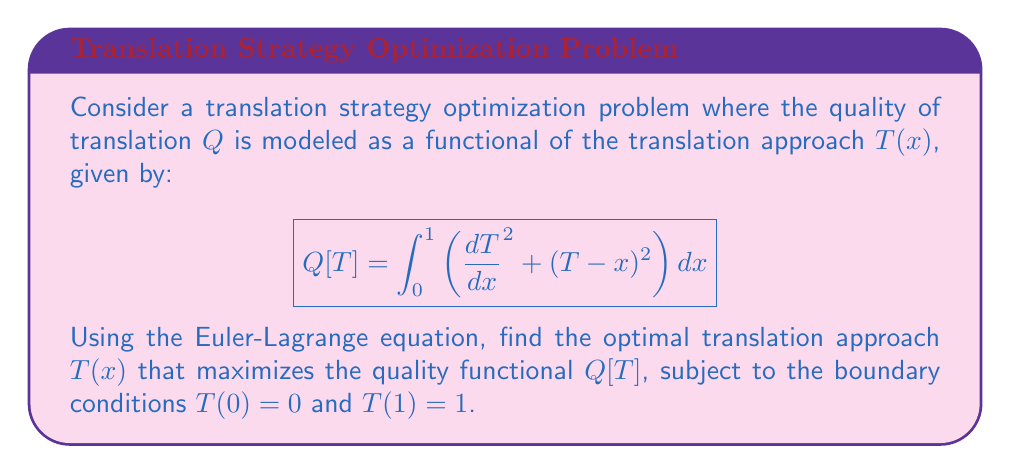Provide a solution to this math problem. 1) The Euler-Lagrange equation for optimizing a functional of the form $\int_a^b F(x,y,y')dx$ is:

   $$\frac{\partial F}{\partial y} - \frac{d}{dx}\left(\frac{\partial F}{\partial y'}\right) = 0$$

2) In our case, $F(x,T,T') = (T')^2 + (T-x)^2$

3) Calculate the partial derivatives:
   $$\frac{\partial F}{\partial T} = 2(T-x)$$
   $$\frac{\partial F}{\partial T'} = 2T'$$

4) Substitute into the Euler-Lagrange equation:
   $$2(T-x) - \frac{d}{dx}(2T') = 0$$

5) Simplify:
   $$2(T-x) - 2T'' = 0$$
   $$T-x - T'' = 0$$

6) Rearrange:
   $$T'' + T = x$$

7) This is a non-homogeneous second-order linear differential equation. The general solution is the sum of the complementary function (solution to $T'' + T = 0$) and a particular integral.

8) The complementary function is:
   $$T_c = A\cos(x) + B\sin(x)$$

9) A particular integral is:
   $$T_p = x$$

10) Therefore, the general solution is:
    $$T(x) = A\cos(x) + B\sin(x) + x$$

11) Apply the boundary conditions:
    $T(0) = 0$: $A + 0 = 0$, so $A = 0$
    $T(1) = 1$: $B\sin(1) + 1 = 1$, so $B\sin(1) = 0$, and $B = 0$

12) The optimal translation approach is:
    $$T(x) = x$$
Answer: $T(x) = x$ 